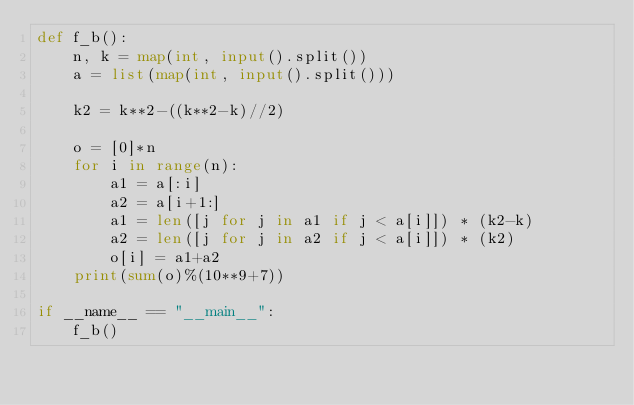Convert code to text. <code><loc_0><loc_0><loc_500><loc_500><_Python_>def f_b():
    n, k = map(int, input().split())
    a = list(map(int, input().split()))

    k2 = k**2-((k**2-k)//2)

    o = [0]*n
    for i in range(n):
        a1 = a[:i]
        a2 = a[i+1:]
        a1 = len([j for j in a1 if j < a[i]]) * (k2-k)
        a2 = len([j for j in a2 if j < a[i]]) * (k2)
        o[i] = a1+a2
    print(sum(o)%(10**9+7))

if __name__ == "__main__":
    f_b()
</code> 